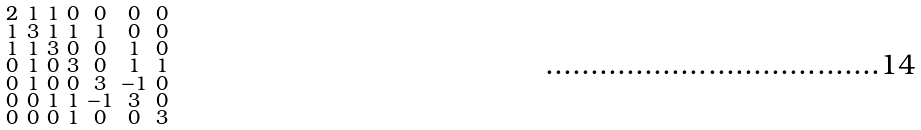Convert formula to latex. <formula><loc_0><loc_0><loc_500><loc_500>\begin{smallmatrix} 2 & 1 & 1 & 0 & 0 & 0 & 0 \\ 1 & 3 & 1 & 1 & 1 & 0 & 0 \\ 1 & 1 & 3 & 0 & 0 & 1 & 0 \\ 0 & 1 & 0 & 3 & 0 & 1 & 1 \\ 0 & 1 & 0 & 0 & 3 & - 1 & 0 \\ 0 & 0 & 1 & 1 & - 1 & 3 & 0 \\ 0 & 0 & 0 & 1 & 0 & 0 & 3 \end{smallmatrix}</formula> 